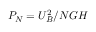Convert formula to latex. <formula><loc_0><loc_0><loc_500><loc_500>P _ { N } = { U } _ { B } ^ { 2 } / N G H</formula> 